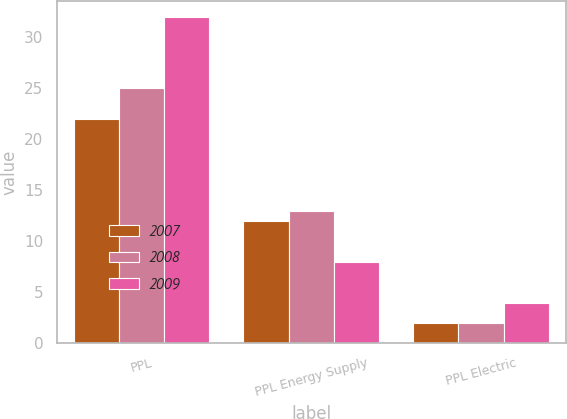Convert chart to OTSL. <chart><loc_0><loc_0><loc_500><loc_500><stacked_bar_chart><ecel><fcel>PPL<fcel>PPL Energy Supply<fcel>PPL Electric<nl><fcel>2007<fcel>22<fcel>12<fcel>2<nl><fcel>2008<fcel>25<fcel>13<fcel>2<nl><fcel>2009<fcel>32<fcel>8<fcel>4<nl></chart> 